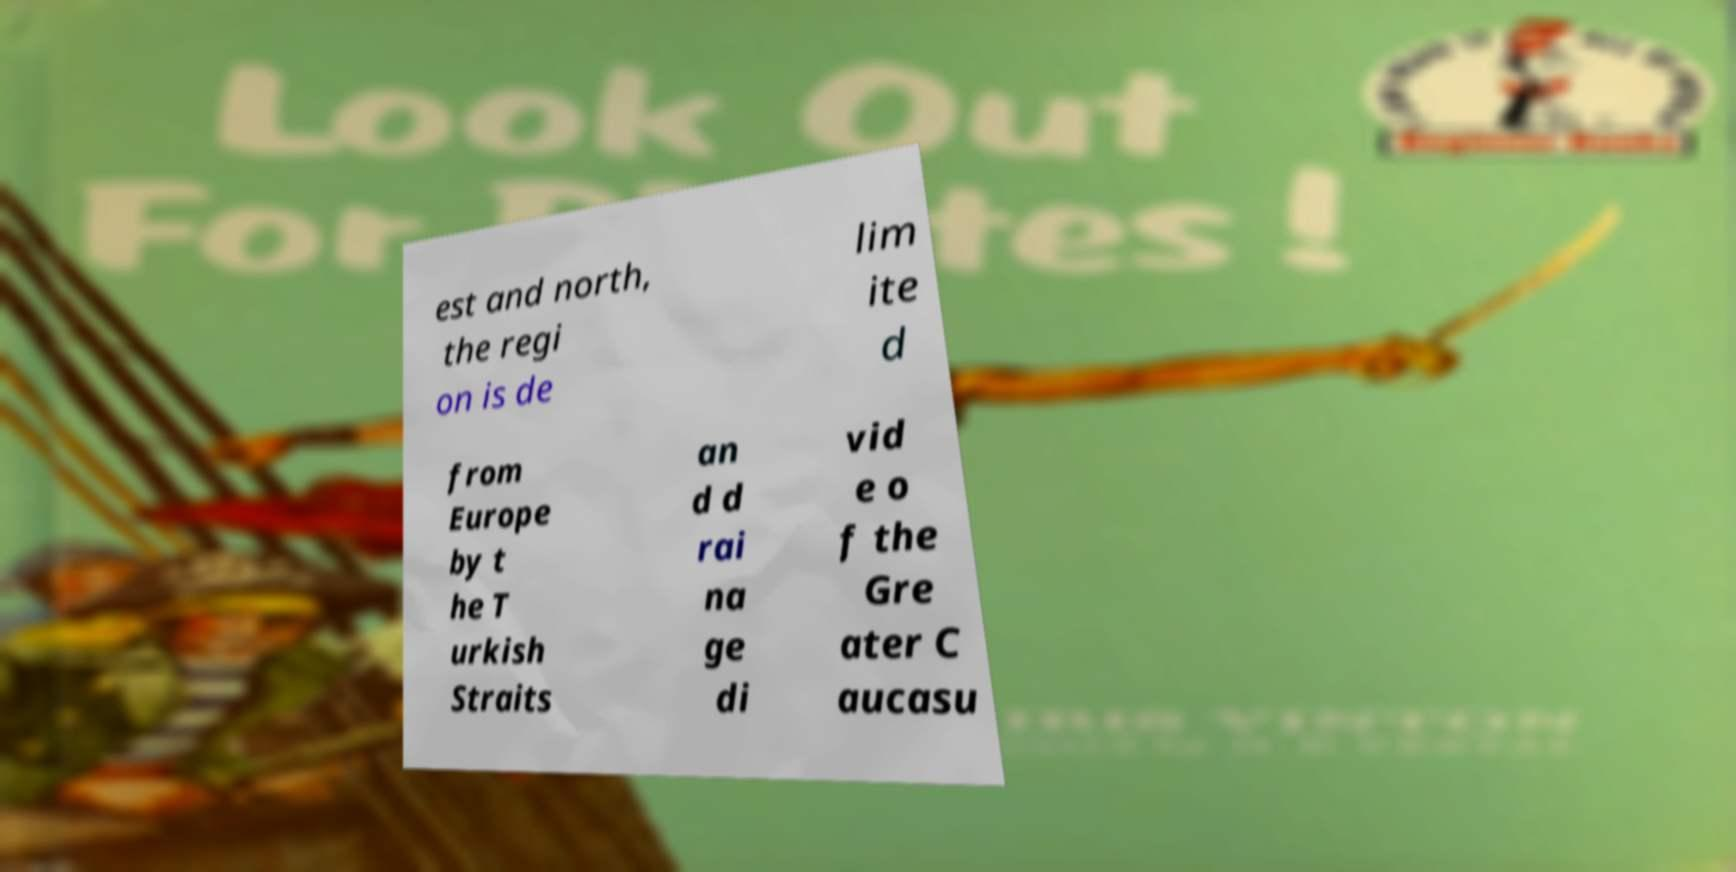Please identify and transcribe the text found in this image. est and north, the regi on is de lim ite d from Europe by t he T urkish Straits an d d rai na ge di vid e o f the Gre ater C aucasu 